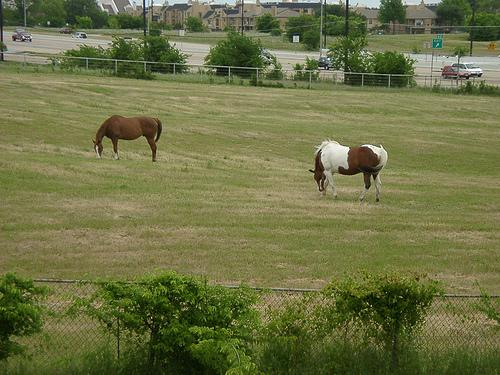Question: who is in the field?
Choices:
A. Cow.
B. Goat.
C. Horse.
D. Pig.
Answer with the letter. Answer: C Question: where are the animals standing?
Choices:
A. In grass.
B. Zoo.
C. Dirt.
D. Water.
Answer with the letter. Answer: A Question: how many animals?
Choices:
A. One.
B. Six.
C. One hundred eight.
D. Two.
Answer with the letter. Answer: D 